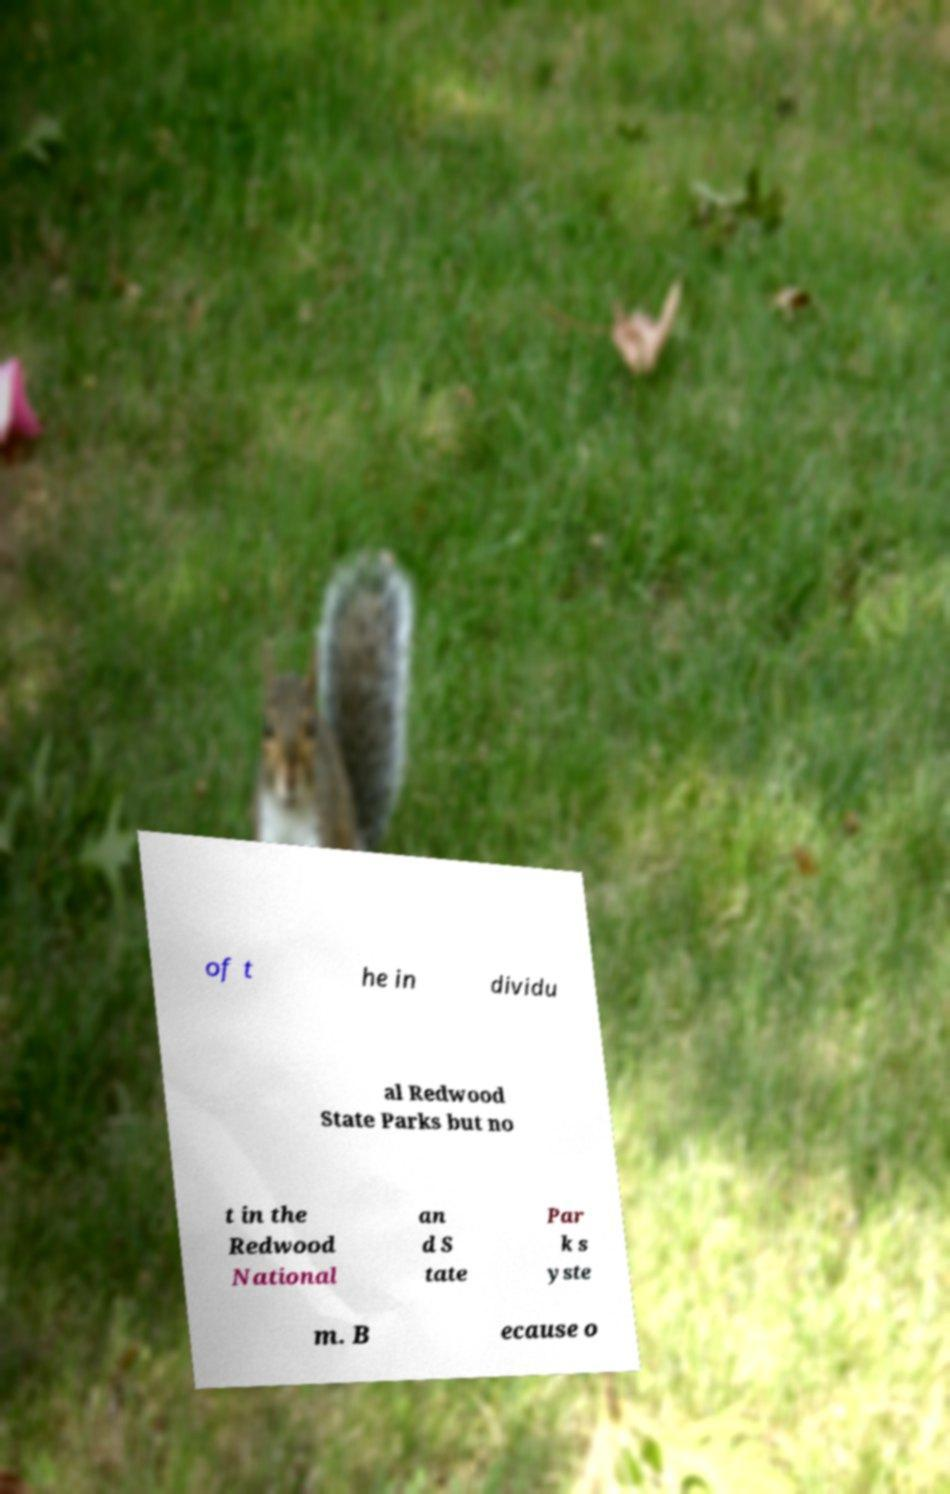I need the written content from this picture converted into text. Can you do that? of t he in dividu al Redwood State Parks but no t in the Redwood National an d S tate Par k s yste m. B ecause o 